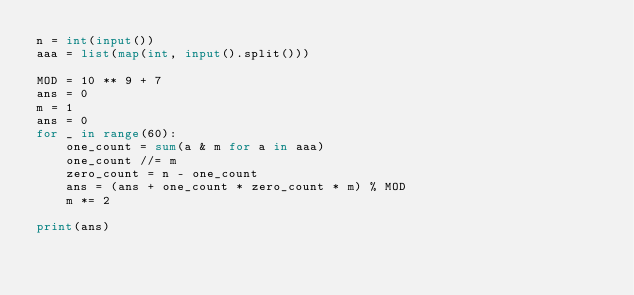<code> <loc_0><loc_0><loc_500><loc_500><_Python_>n = int(input())
aaa = list(map(int, input().split()))

MOD = 10 ** 9 + 7
ans = 0
m = 1
ans = 0
for _ in range(60):
    one_count = sum(a & m for a in aaa)
    one_count //= m
    zero_count = n - one_count
    ans = (ans + one_count * zero_count * m) % MOD
    m *= 2
        
print(ans)
</code> 